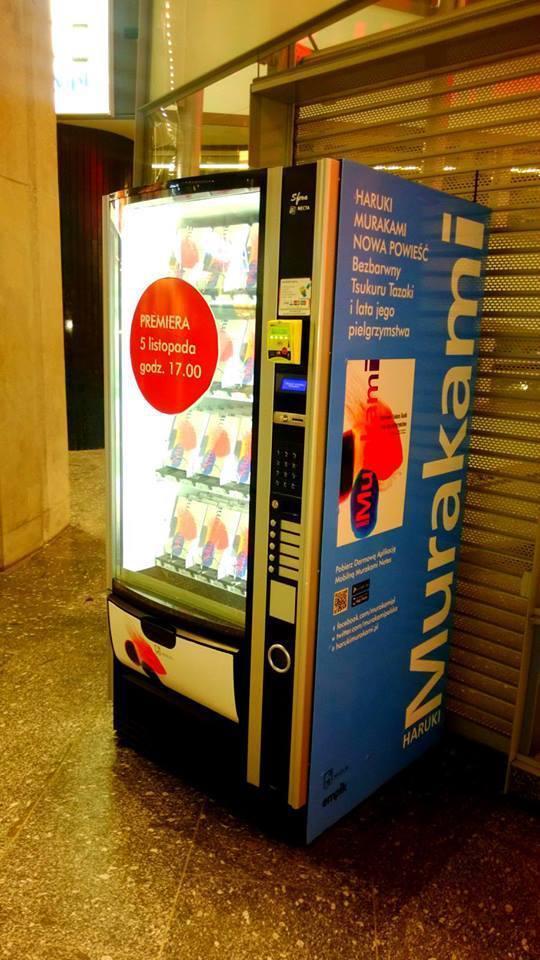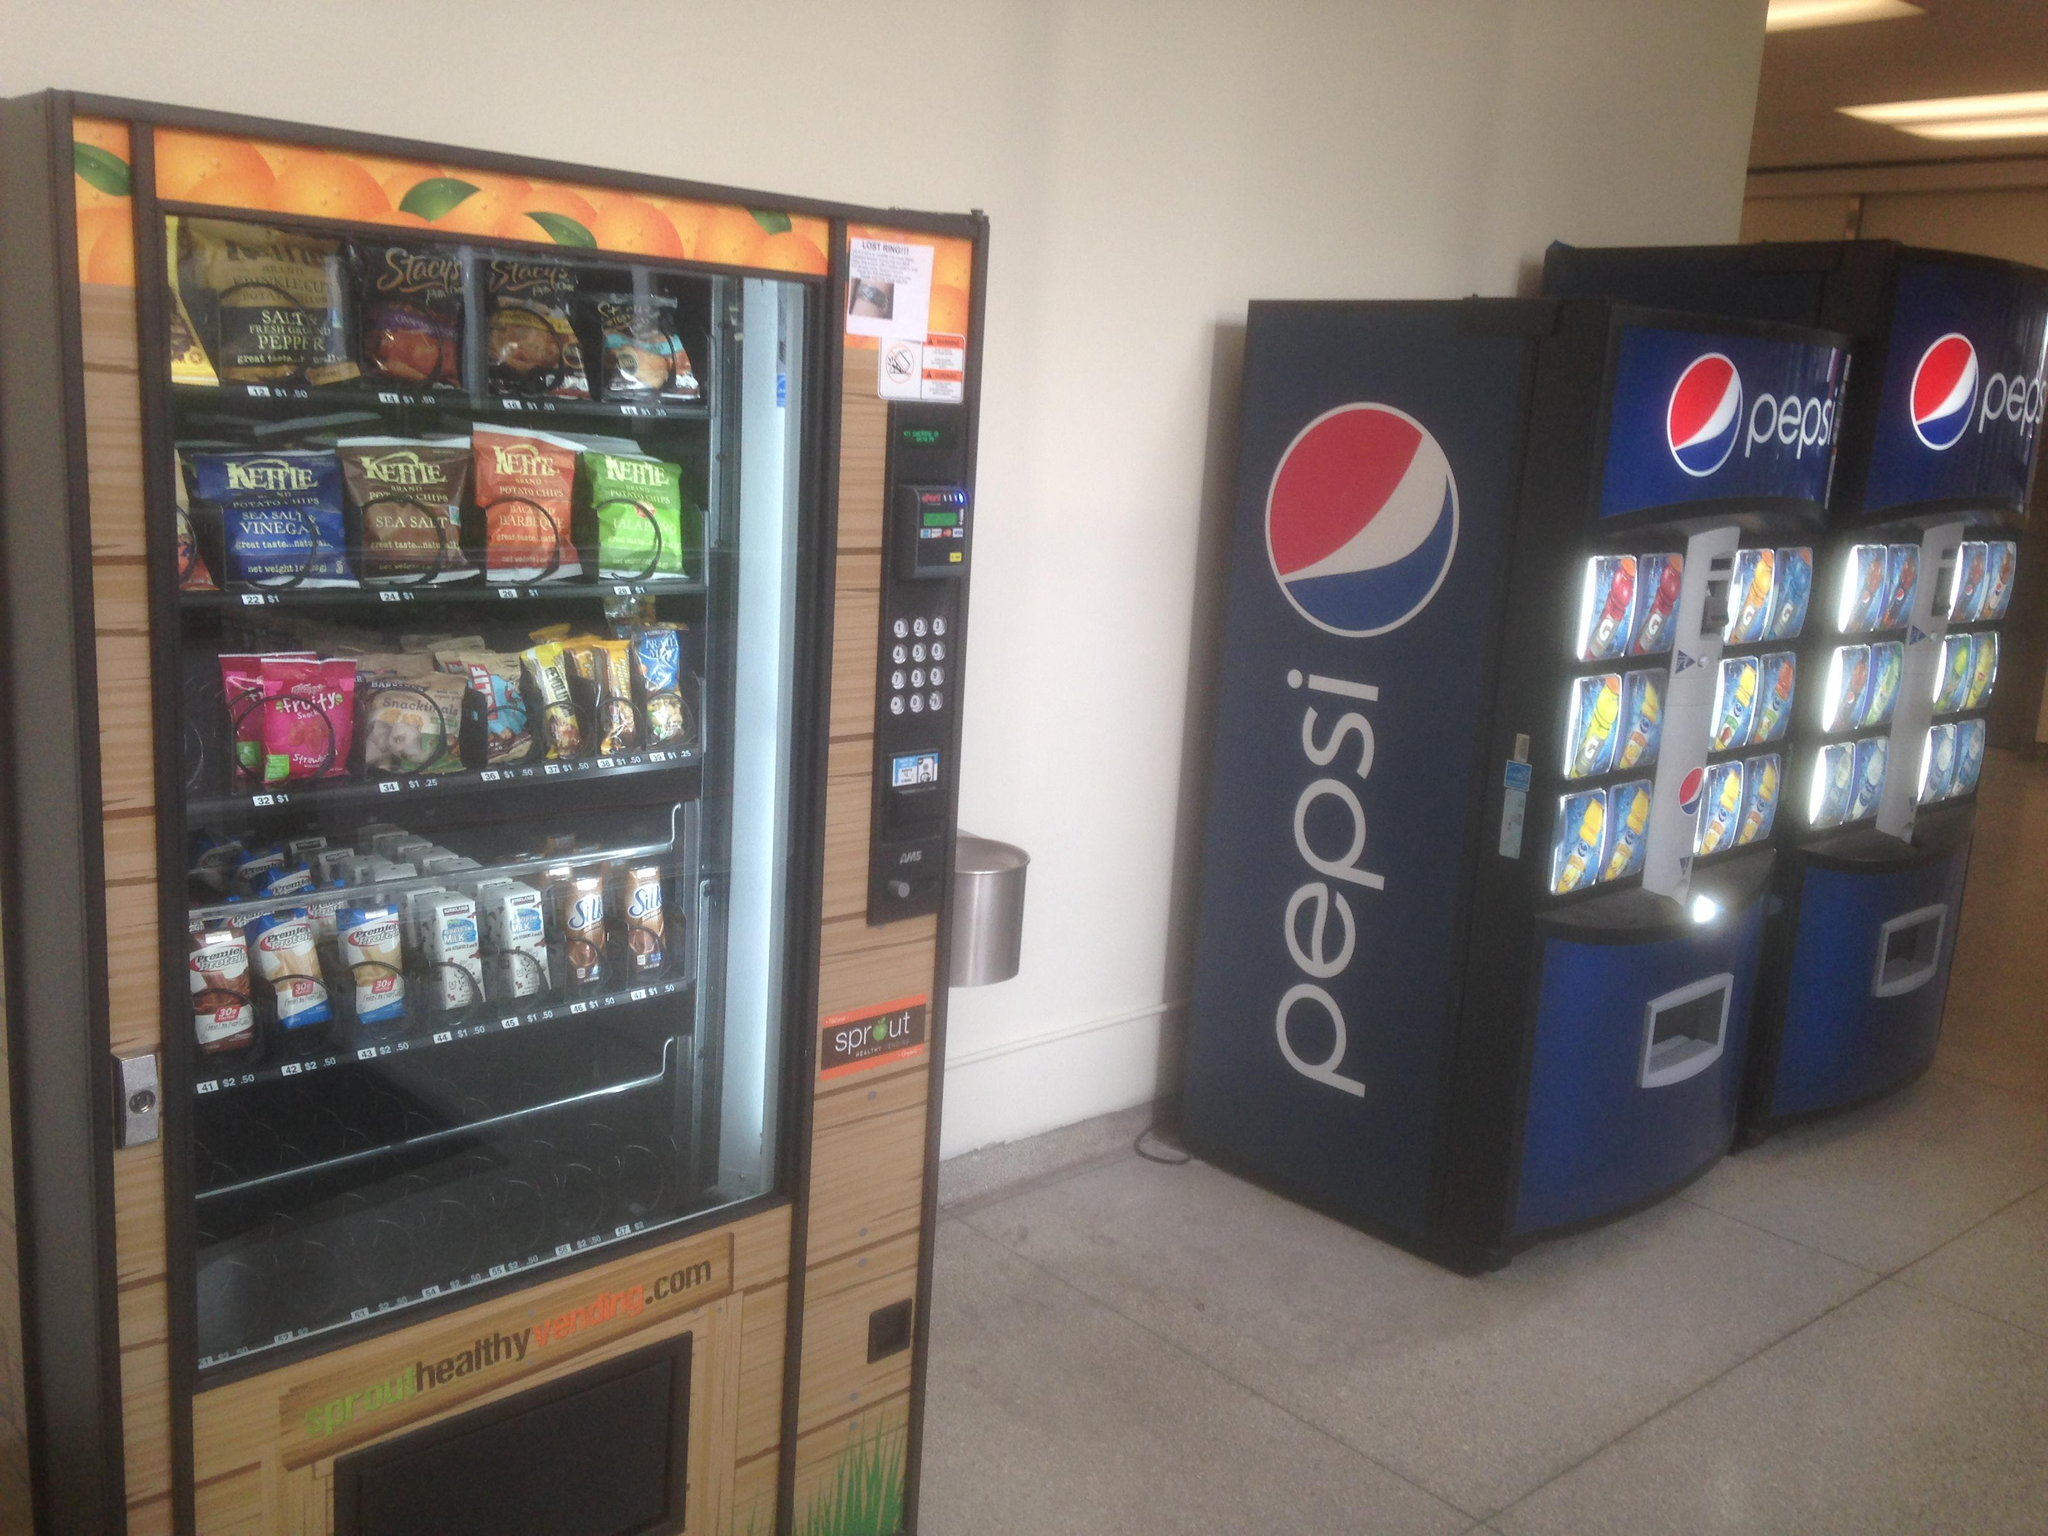The first image is the image on the left, the second image is the image on the right. For the images shown, is this caption "One image shows a horizontal row of exactly three vending machines, with none more than about a foot apart." true? Answer yes or no. No. 